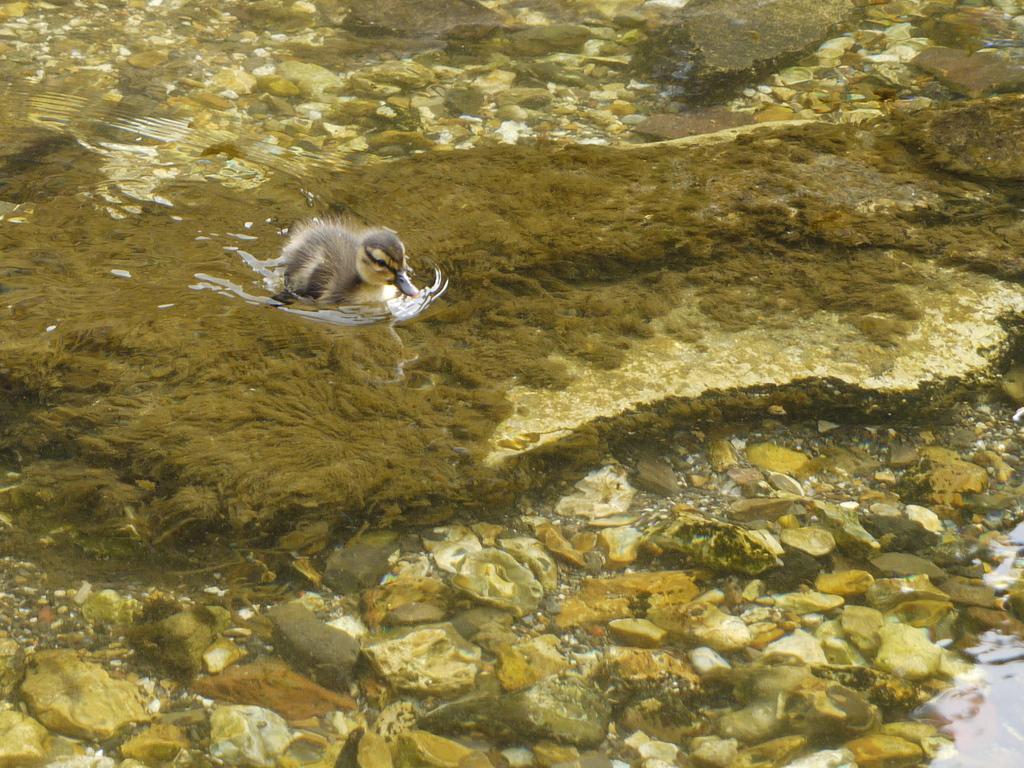Please provide a concise description of this image. On the left side, there is a bird on the moss, which is wet. Beside this moss, there are stones. On the right side, there is water. In the background, there are stones. 